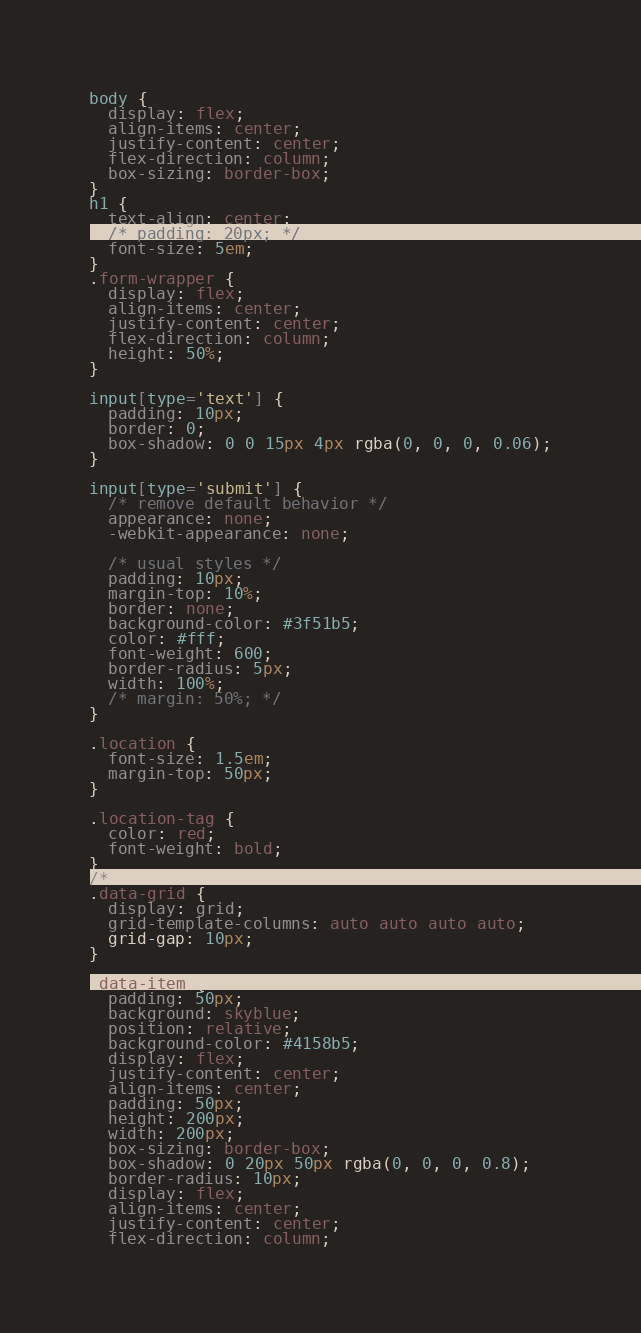<code> <loc_0><loc_0><loc_500><loc_500><_CSS_>body {
  display: flex;
  align-items: center;
  justify-content: center;
  flex-direction: column;
  box-sizing: border-box;
}
h1 {
  text-align: center;
  /* padding: 20px; */
  font-size: 5em;
}
.form-wrapper {
  display: flex;
  align-items: center;
  justify-content: center;
  flex-direction: column;
  height: 50%;
}

input[type='text'] {
  padding: 10px;
  border: 0;
  box-shadow: 0 0 15px 4px rgba(0, 0, 0, 0.06);
}

input[type='submit'] {
  /* remove default behavior */
  appearance: none;
  -webkit-appearance: none;

  /* usual styles */
  padding: 10px;
  margin-top: 10%;
  border: none;
  background-color: #3f51b5;
  color: #fff;
  font-weight: 600;
  border-radius: 5px;
  width: 100%;
  /* margin: 50%; */
}

.location {
  font-size: 1.5em;
  margin-top: 50px;
}

.location-tag {
  color: red;
  font-weight: bold;
}
/*
.data-grid {
  display: grid;
  grid-template-columns: auto auto auto auto;
  grid-gap: 10px;
}

.data-item {
  padding: 50px;
  background: skyblue;
  position: relative;
  background-color: #4158b5;
  display: flex;
  justify-content: center;
  align-items: center;
  padding: 50px;
  height: 200px;
  width: 200px;
  box-sizing: border-box;
  box-shadow: 0 20px 50px rgba(0, 0, 0, 0.8);
  border-radius: 10px;
  display: flex;
  align-items: center;
  justify-content: center;
  flex-direction: column;</code> 